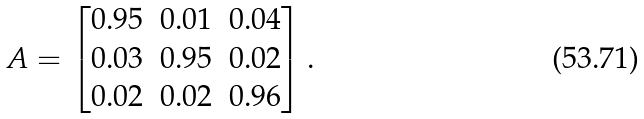Convert formula to latex. <formula><loc_0><loc_0><loc_500><loc_500>A = \begin{bmatrix} 0 . 9 5 & 0 . 0 1 & 0 . 0 4 \\ 0 . 0 3 & 0 . 9 5 & 0 . 0 2 \\ 0 . 0 2 & 0 . 0 2 & 0 . 9 6 \end{bmatrix} .</formula> 